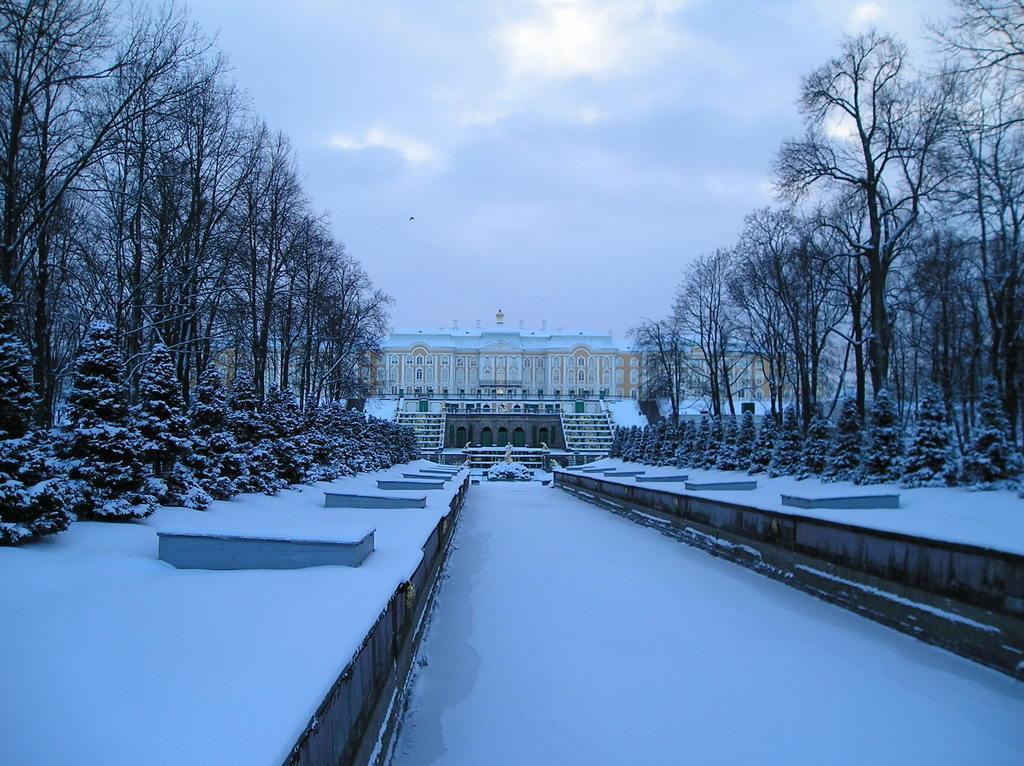Please provide a concise description of this image. In this image there is a building, few trees and the ground covered with snow, there are few clouds in the sky. 